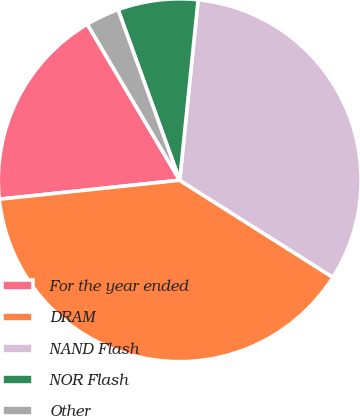Convert chart to OTSL. <chart><loc_0><loc_0><loc_500><loc_500><pie_chart><fcel>For the year ended<fcel>DRAM<fcel>NAND Flash<fcel>NOR Flash<fcel>Other<nl><fcel>18.16%<fcel>39.34%<fcel>32.37%<fcel>7.14%<fcel>2.99%<nl></chart> 